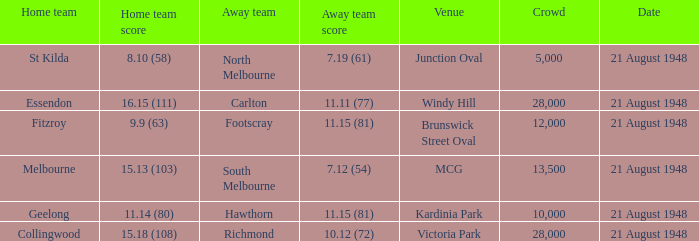If the Crowd is larger than 10,000 and the Away team score is 11.15 (81), what is the venue being played at? Brunswick Street Oval. 